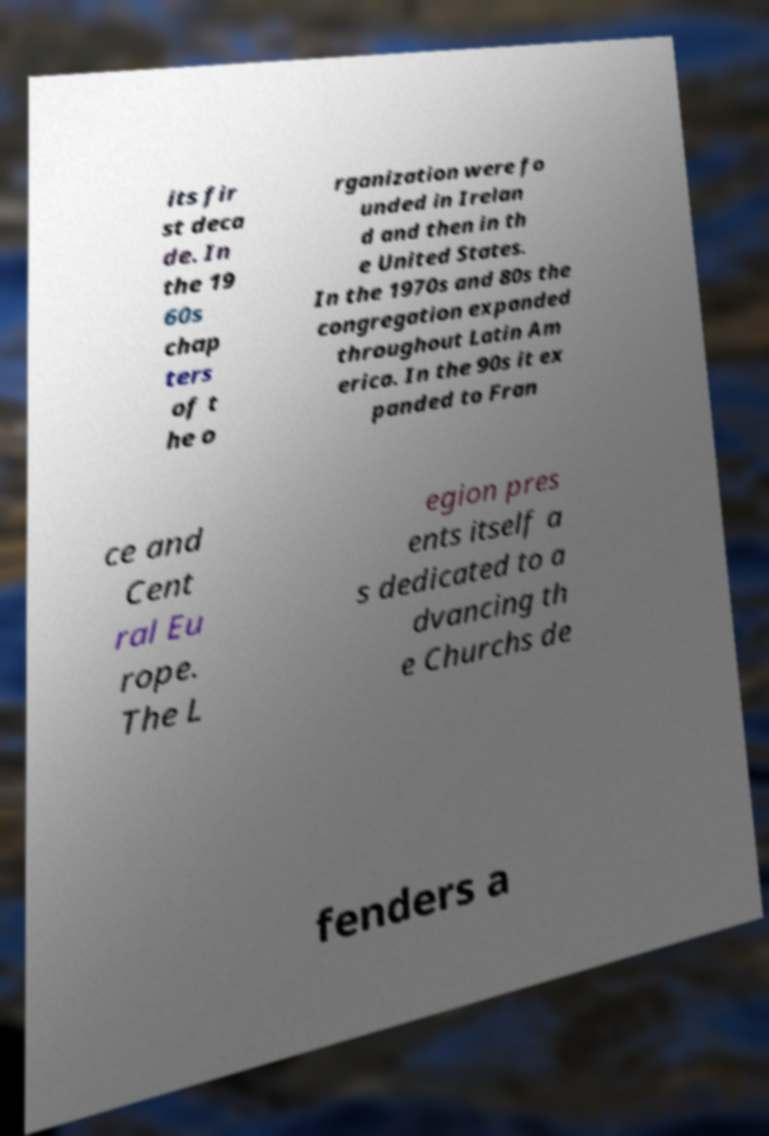Could you assist in decoding the text presented in this image and type it out clearly? its fir st deca de. In the 19 60s chap ters of t he o rganization were fo unded in Irelan d and then in th e United States. In the 1970s and 80s the congregation expanded throughout Latin Am erica. In the 90s it ex panded to Fran ce and Cent ral Eu rope. The L egion pres ents itself a s dedicated to a dvancing th e Churchs de fenders a 